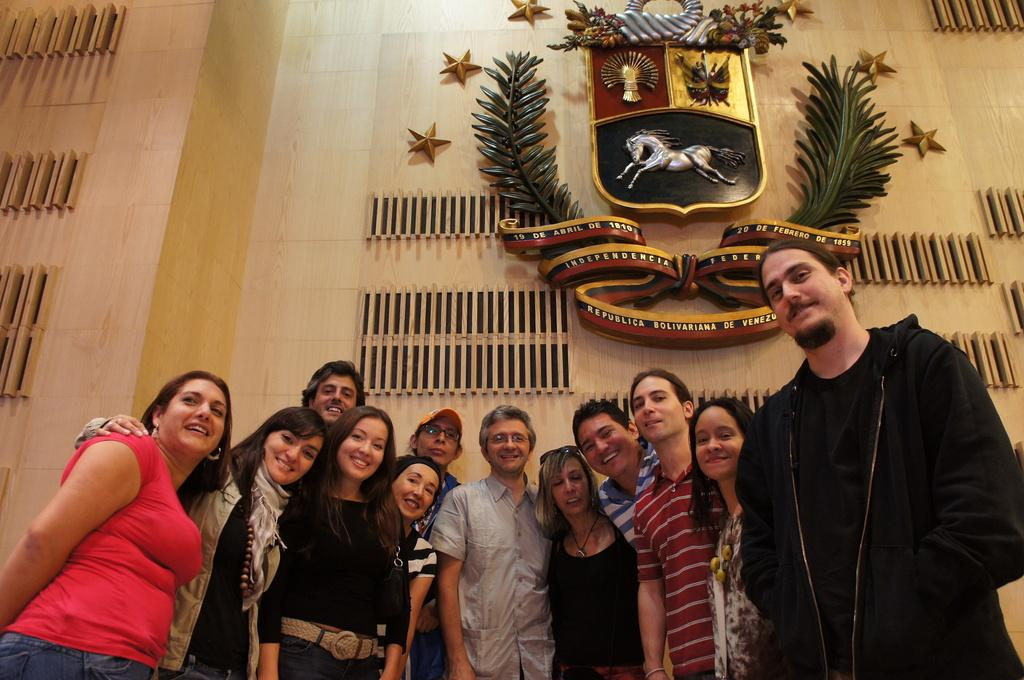How many people are in the image? There are many men and women in the image. Where are the people standing in the image? The people are standing in front of a wall. What can be seen on the wall? The wall has a symbol on it, and there are plants and a statue of stars depicted on it. What is the general expression of the people in the image? All the people in the image are smiling. Can you see any fish swimming in the air in the image? There are no fish or air present in the image; it features a group of people standing in front of a wall with various symbols and decorations. 